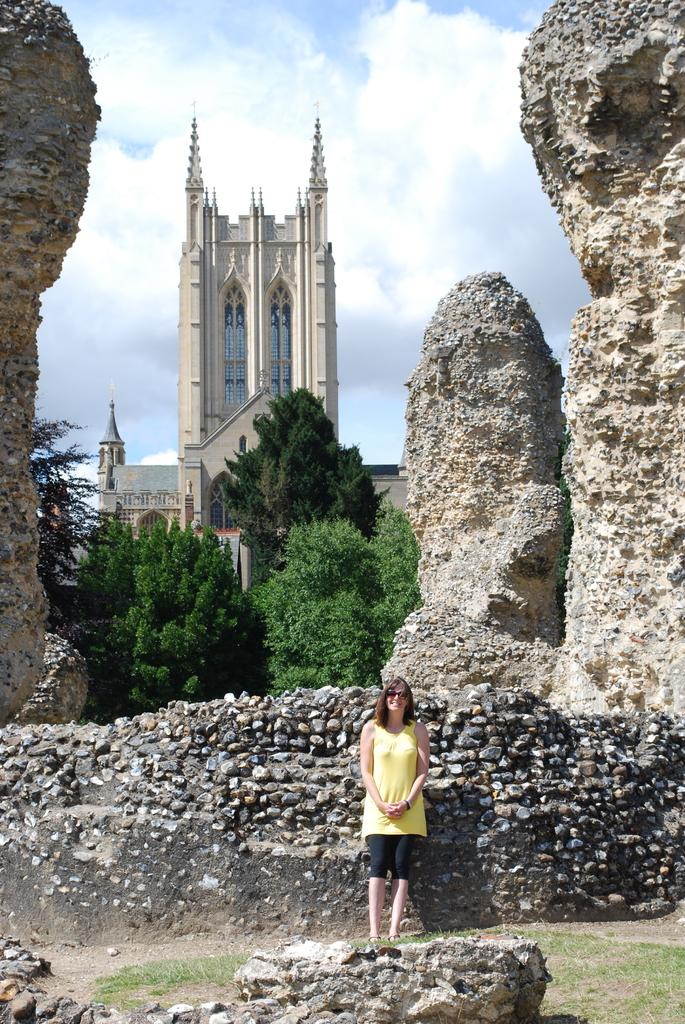Who is present in the image? There is a woman in the image. What is the woman doing in the image? The woman is standing. What is the woman wearing in the image? The woman is wearing a yellow dress. What can be seen in the background of the image? There are trees and a building in the background of the image. What is visible in the sky in the image? There are clouds in the sky, and the sky is visible in the background of the image. What type of nail is being used to process documents in the image? There is no nail or document processing visible in the image; it features a woman standing in a setting with trees, a building, and clouds in the sky. 